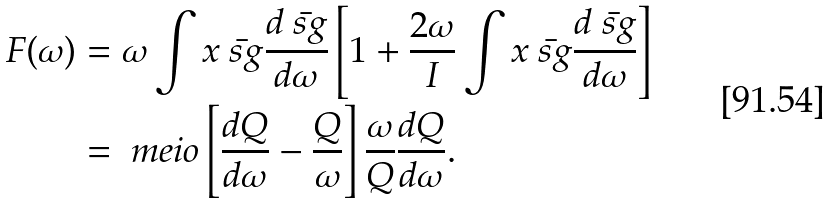Convert formula to latex. <formula><loc_0><loc_0><loc_500><loc_500>F ( \omega ) & = \omega \int x \bar { \ s g } \frac { d \bar { \ s g } } { d \omega } \left [ 1 + \frac { 2 \omega } { I } \int x \bar { \ s g } \frac { d \bar { \ s g } } { d \omega } \right ] \\ & = \ m e i o \left [ \frac { d Q } { d \omega } - \frac { Q } { \omega } \right ] \frac { \omega } { Q } \frac { d Q } { d \omega } .</formula> 